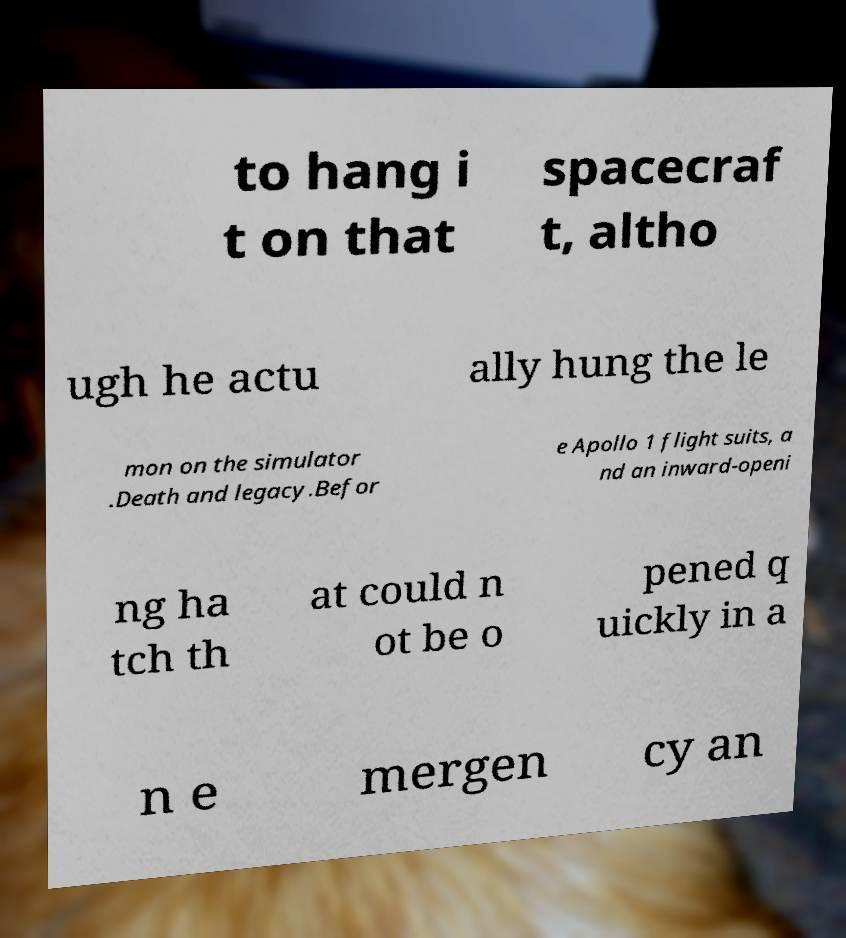Can you accurately transcribe the text from the provided image for me? to hang i t on that spacecraf t, altho ugh he actu ally hung the le mon on the simulator .Death and legacy.Befor e Apollo 1 flight suits, a nd an inward-openi ng ha tch th at could n ot be o pened q uickly in a n e mergen cy an 